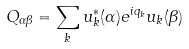Convert formula to latex. <formula><loc_0><loc_0><loc_500><loc_500>Q _ { \alpha \beta } = \sum _ { k } u _ { k } ^ { * } ( \alpha ) e ^ { i q _ { k } } u _ { k } ( \beta )</formula> 